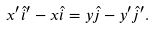<formula> <loc_0><loc_0><loc_500><loc_500>x ^ { \prime } \hat { i } ^ { \prime } - x \hat { i } = y \hat { j } - y ^ { \prime } \hat { j } ^ { \prime } .</formula> 